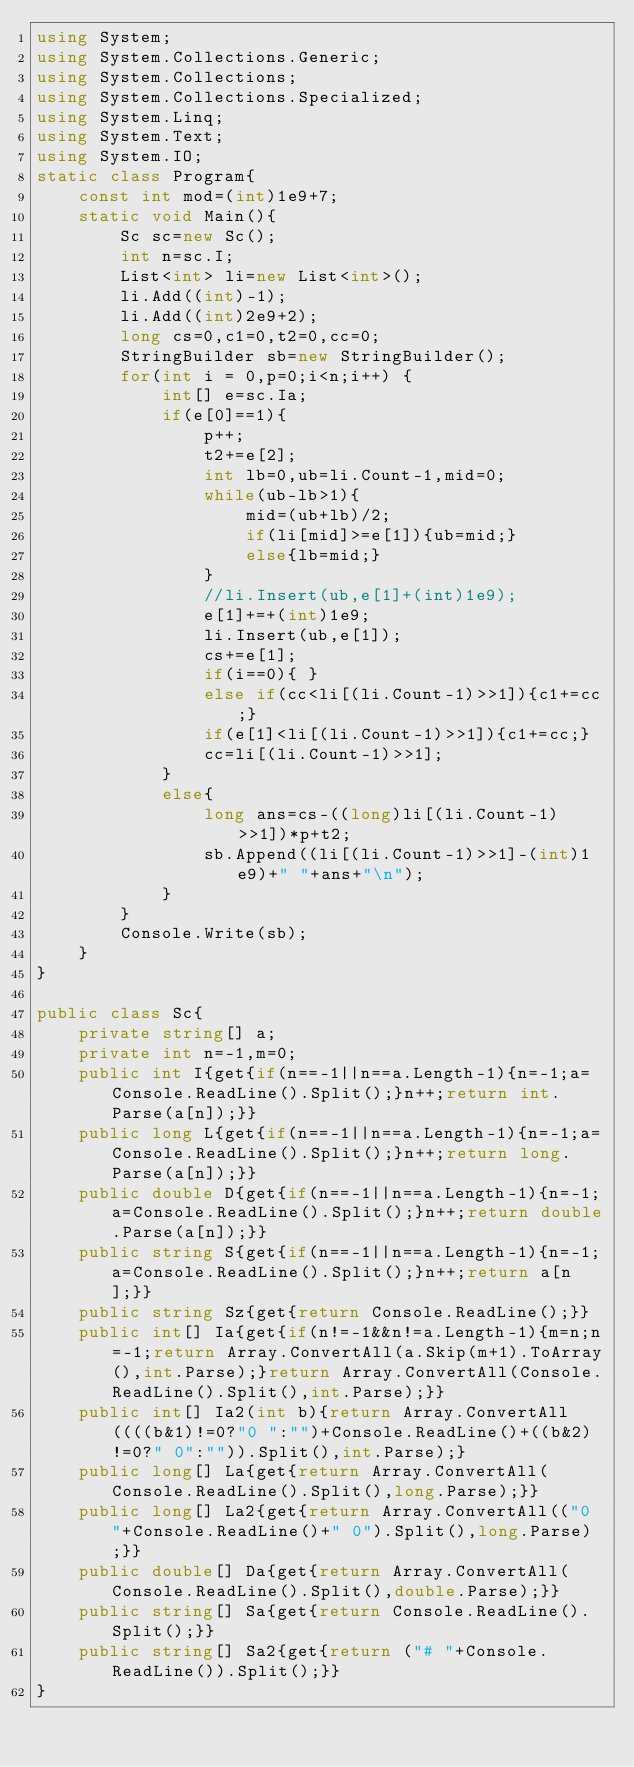Convert code to text. <code><loc_0><loc_0><loc_500><loc_500><_C#_>using System;
using System.Collections.Generic;
using System.Collections;
using System.Collections.Specialized;
using System.Linq;
using System.Text;
using System.IO;
static class Program{
	const int mod=(int)1e9+7;
	static void Main(){
		Sc sc=new Sc();
		int n=sc.I;
		List<int> li=new List<int>();
		li.Add((int)-1);
		li.Add((int)2e9+2);
		long cs=0,c1=0,t2=0,cc=0;
		StringBuilder sb=new StringBuilder();
		for(int i = 0,p=0;i<n;i++) {
			int[] e=sc.Ia;
			if(e[0]==1){
				p++;
				t2+=e[2];
				int lb=0,ub=li.Count-1,mid=0;
				while(ub-lb>1){
					mid=(ub+lb)/2;
					if(li[mid]>=e[1]){ub=mid;}
					else{lb=mid;}
				}
				//li.Insert(ub,e[1]+(int)1e9);
				e[1]+=+(int)1e9;
				li.Insert(ub,e[1]);
				cs+=e[1];
				if(i==0){ }
				else if(cc<li[(li.Count-1)>>1]){c1+=cc;}
				if(e[1]<li[(li.Count-1)>>1]){c1+=cc;}
				cc=li[(li.Count-1)>>1];
			}
			else{
				long ans=cs-((long)li[(li.Count-1)>>1])*p+t2;
				sb.Append((li[(li.Count-1)>>1]-(int)1e9)+" "+ans+"\n");
			}
		}
		Console.Write(sb);
	}
}

public class Sc{
	private string[] a;
	private int n=-1,m=0;
	public int I{get{if(n==-1||n==a.Length-1){n=-1;a=Console.ReadLine().Split();}n++;return int.Parse(a[n]);}}
	public long L{get{if(n==-1||n==a.Length-1){n=-1;a=Console.ReadLine().Split();}n++;return long.Parse(a[n]);}}
	public double D{get{if(n==-1||n==a.Length-1){n=-1;a=Console.ReadLine().Split();}n++;return double.Parse(a[n]);}}
	public string S{get{if(n==-1||n==a.Length-1){n=-1;a=Console.ReadLine().Split();}n++;return a[n];}}
	public string Sz{get{return Console.ReadLine();}}
	public int[] Ia{get{if(n!=-1&&n!=a.Length-1){m=n;n=-1;return Array.ConvertAll(a.Skip(m+1).ToArray(),int.Parse);}return Array.ConvertAll(Console.ReadLine().Split(),int.Parse);}}
	public int[] Ia2(int b){return Array.ConvertAll((((b&1)!=0?"0 ":"")+Console.ReadLine()+((b&2)!=0?" 0":"")).Split(),int.Parse);}
	public long[] La{get{return Array.ConvertAll(Console.ReadLine().Split(),long.Parse);}}
	public long[] La2{get{return Array.ConvertAll(("0 "+Console.ReadLine()+" 0").Split(),long.Parse);}}
	public double[] Da{get{return Array.ConvertAll(Console.ReadLine().Split(),double.Parse);}}
	public string[] Sa{get{return Console.ReadLine().Split();}}
	public string[] Sa2{get{return ("# "+Console.ReadLine()).Split();}}
}
</code> 